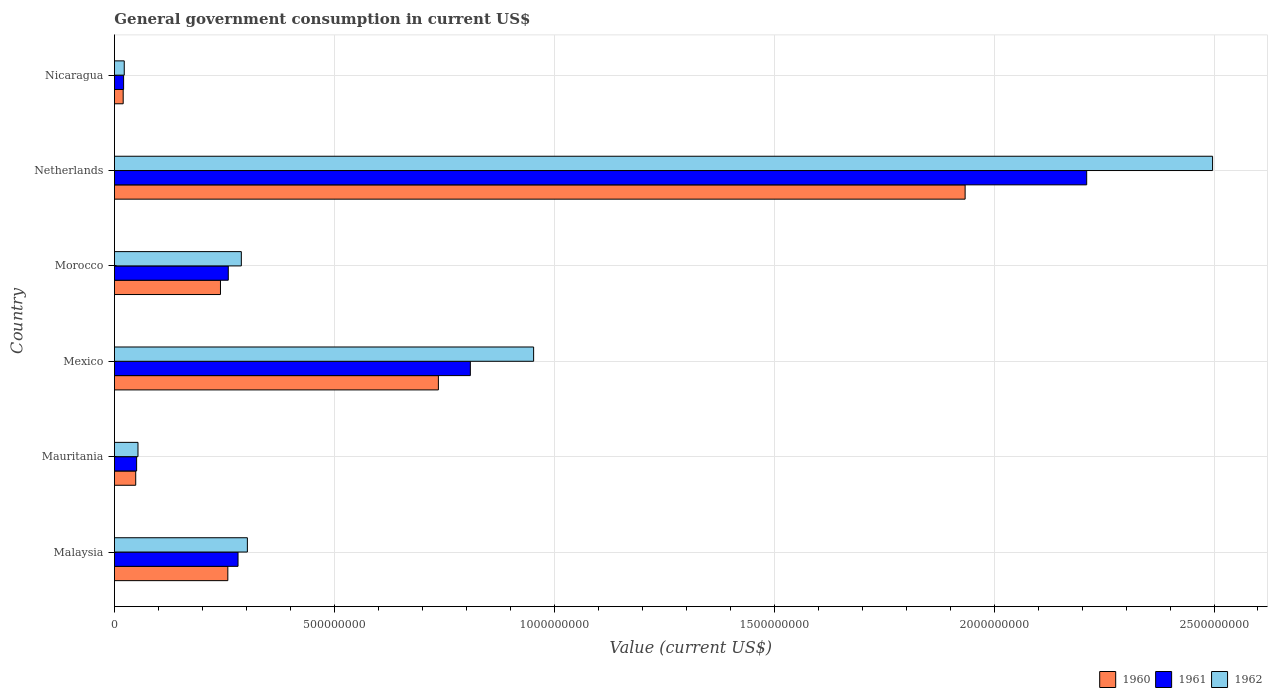How many bars are there on the 3rd tick from the top?
Your answer should be very brief. 3. What is the label of the 2nd group of bars from the top?
Provide a short and direct response. Netherlands. In how many cases, is the number of bars for a given country not equal to the number of legend labels?
Provide a short and direct response. 0. What is the government conusmption in 1962 in Netherlands?
Offer a very short reply. 2.50e+09. Across all countries, what is the maximum government conusmption in 1960?
Provide a short and direct response. 1.93e+09. Across all countries, what is the minimum government conusmption in 1962?
Offer a very short reply. 2.23e+07. In which country was the government conusmption in 1961 maximum?
Provide a succinct answer. Netherlands. In which country was the government conusmption in 1960 minimum?
Your response must be concise. Nicaragua. What is the total government conusmption in 1962 in the graph?
Ensure brevity in your answer.  4.12e+09. What is the difference between the government conusmption in 1961 in Mauritania and that in Netherlands?
Ensure brevity in your answer.  -2.16e+09. What is the difference between the government conusmption in 1961 in Netherlands and the government conusmption in 1960 in Mauritania?
Your response must be concise. 2.16e+09. What is the average government conusmption in 1961 per country?
Ensure brevity in your answer.  6.05e+08. What is the difference between the government conusmption in 1962 and government conusmption in 1961 in Morocco?
Keep it short and to the point. 2.96e+07. What is the ratio of the government conusmption in 1961 in Malaysia to that in Morocco?
Provide a succinct answer. 1.09. What is the difference between the highest and the second highest government conusmption in 1960?
Offer a very short reply. 1.20e+09. What is the difference between the highest and the lowest government conusmption in 1962?
Provide a succinct answer. 2.47e+09. In how many countries, is the government conusmption in 1960 greater than the average government conusmption in 1960 taken over all countries?
Your response must be concise. 2. Is the sum of the government conusmption in 1962 in Mauritania and Mexico greater than the maximum government conusmption in 1960 across all countries?
Give a very brief answer. No. Are all the bars in the graph horizontal?
Provide a short and direct response. Yes. What is the difference between two consecutive major ticks on the X-axis?
Make the answer very short. 5.00e+08. Are the values on the major ticks of X-axis written in scientific E-notation?
Your answer should be compact. No. Does the graph contain any zero values?
Provide a succinct answer. No. Does the graph contain grids?
Give a very brief answer. Yes. Where does the legend appear in the graph?
Keep it short and to the point. Bottom right. What is the title of the graph?
Provide a short and direct response. General government consumption in current US$. Does "1994" appear as one of the legend labels in the graph?
Ensure brevity in your answer.  No. What is the label or title of the X-axis?
Offer a very short reply. Value (current US$). What is the label or title of the Y-axis?
Give a very brief answer. Country. What is the Value (current US$) of 1960 in Malaysia?
Your answer should be compact. 2.58e+08. What is the Value (current US$) in 1961 in Malaysia?
Provide a short and direct response. 2.81e+08. What is the Value (current US$) in 1962 in Malaysia?
Give a very brief answer. 3.02e+08. What is the Value (current US$) of 1960 in Mauritania?
Provide a succinct answer. 4.84e+07. What is the Value (current US$) of 1961 in Mauritania?
Offer a very short reply. 5.05e+07. What is the Value (current US$) in 1962 in Mauritania?
Keep it short and to the point. 5.36e+07. What is the Value (current US$) in 1960 in Mexico?
Make the answer very short. 7.37e+08. What is the Value (current US$) in 1961 in Mexico?
Offer a terse response. 8.09e+08. What is the Value (current US$) in 1962 in Mexico?
Keep it short and to the point. 9.53e+08. What is the Value (current US$) of 1960 in Morocco?
Offer a very short reply. 2.41e+08. What is the Value (current US$) of 1961 in Morocco?
Offer a very short reply. 2.59e+08. What is the Value (current US$) in 1962 in Morocco?
Ensure brevity in your answer.  2.89e+08. What is the Value (current US$) in 1960 in Netherlands?
Provide a short and direct response. 1.93e+09. What is the Value (current US$) in 1961 in Netherlands?
Keep it short and to the point. 2.21e+09. What is the Value (current US$) in 1962 in Netherlands?
Ensure brevity in your answer.  2.50e+09. What is the Value (current US$) in 1960 in Nicaragua?
Ensure brevity in your answer.  1.99e+07. What is the Value (current US$) in 1961 in Nicaragua?
Your answer should be compact. 2.09e+07. What is the Value (current US$) of 1962 in Nicaragua?
Your answer should be compact. 2.23e+07. Across all countries, what is the maximum Value (current US$) of 1960?
Provide a short and direct response. 1.93e+09. Across all countries, what is the maximum Value (current US$) of 1961?
Offer a terse response. 2.21e+09. Across all countries, what is the maximum Value (current US$) of 1962?
Your response must be concise. 2.50e+09. Across all countries, what is the minimum Value (current US$) in 1960?
Ensure brevity in your answer.  1.99e+07. Across all countries, what is the minimum Value (current US$) of 1961?
Make the answer very short. 2.09e+07. Across all countries, what is the minimum Value (current US$) of 1962?
Provide a short and direct response. 2.23e+07. What is the total Value (current US$) of 1960 in the graph?
Make the answer very short. 3.24e+09. What is the total Value (current US$) of 1961 in the graph?
Your response must be concise. 3.63e+09. What is the total Value (current US$) in 1962 in the graph?
Make the answer very short. 4.12e+09. What is the difference between the Value (current US$) of 1960 in Malaysia and that in Mauritania?
Offer a terse response. 2.09e+08. What is the difference between the Value (current US$) of 1961 in Malaysia and that in Mauritania?
Your answer should be very brief. 2.31e+08. What is the difference between the Value (current US$) in 1962 in Malaysia and that in Mauritania?
Ensure brevity in your answer.  2.49e+08. What is the difference between the Value (current US$) of 1960 in Malaysia and that in Mexico?
Give a very brief answer. -4.79e+08. What is the difference between the Value (current US$) of 1961 in Malaysia and that in Mexico?
Your response must be concise. -5.28e+08. What is the difference between the Value (current US$) in 1962 in Malaysia and that in Mexico?
Your answer should be compact. -6.51e+08. What is the difference between the Value (current US$) in 1960 in Malaysia and that in Morocco?
Give a very brief answer. 1.67e+07. What is the difference between the Value (current US$) of 1961 in Malaysia and that in Morocco?
Offer a terse response. 2.21e+07. What is the difference between the Value (current US$) in 1962 in Malaysia and that in Morocco?
Keep it short and to the point. 1.37e+07. What is the difference between the Value (current US$) of 1960 in Malaysia and that in Netherlands?
Offer a very short reply. -1.68e+09. What is the difference between the Value (current US$) in 1961 in Malaysia and that in Netherlands?
Provide a short and direct response. -1.93e+09. What is the difference between the Value (current US$) of 1962 in Malaysia and that in Netherlands?
Your answer should be very brief. -2.19e+09. What is the difference between the Value (current US$) of 1960 in Malaysia and that in Nicaragua?
Make the answer very short. 2.38e+08. What is the difference between the Value (current US$) in 1961 in Malaysia and that in Nicaragua?
Keep it short and to the point. 2.60e+08. What is the difference between the Value (current US$) in 1962 in Malaysia and that in Nicaragua?
Your response must be concise. 2.80e+08. What is the difference between the Value (current US$) in 1960 in Mauritania and that in Mexico?
Ensure brevity in your answer.  -6.88e+08. What is the difference between the Value (current US$) of 1961 in Mauritania and that in Mexico?
Offer a terse response. -7.59e+08. What is the difference between the Value (current US$) of 1962 in Mauritania and that in Mexico?
Make the answer very short. -9.00e+08. What is the difference between the Value (current US$) of 1960 in Mauritania and that in Morocco?
Provide a succinct answer. -1.93e+08. What is the difference between the Value (current US$) in 1961 in Mauritania and that in Morocco?
Provide a succinct answer. -2.08e+08. What is the difference between the Value (current US$) in 1962 in Mauritania and that in Morocco?
Your answer should be very brief. -2.35e+08. What is the difference between the Value (current US$) in 1960 in Mauritania and that in Netherlands?
Give a very brief answer. -1.89e+09. What is the difference between the Value (current US$) of 1961 in Mauritania and that in Netherlands?
Keep it short and to the point. -2.16e+09. What is the difference between the Value (current US$) of 1962 in Mauritania and that in Netherlands?
Your answer should be compact. -2.44e+09. What is the difference between the Value (current US$) in 1960 in Mauritania and that in Nicaragua?
Provide a short and direct response. 2.85e+07. What is the difference between the Value (current US$) of 1961 in Mauritania and that in Nicaragua?
Offer a very short reply. 2.96e+07. What is the difference between the Value (current US$) in 1962 in Mauritania and that in Nicaragua?
Keep it short and to the point. 3.12e+07. What is the difference between the Value (current US$) of 1960 in Mexico and that in Morocco?
Your answer should be compact. 4.95e+08. What is the difference between the Value (current US$) of 1961 in Mexico and that in Morocco?
Give a very brief answer. 5.50e+08. What is the difference between the Value (current US$) of 1962 in Mexico and that in Morocco?
Offer a very short reply. 6.65e+08. What is the difference between the Value (current US$) in 1960 in Mexico and that in Netherlands?
Make the answer very short. -1.20e+09. What is the difference between the Value (current US$) in 1961 in Mexico and that in Netherlands?
Your response must be concise. -1.40e+09. What is the difference between the Value (current US$) of 1962 in Mexico and that in Netherlands?
Offer a terse response. -1.54e+09. What is the difference between the Value (current US$) of 1960 in Mexico and that in Nicaragua?
Give a very brief answer. 7.17e+08. What is the difference between the Value (current US$) of 1961 in Mexico and that in Nicaragua?
Keep it short and to the point. 7.88e+08. What is the difference between the Value (current US$) in 1962 in Mexico and that in Nicaragua?
Offer a very short reply. 9.31e+08. What is the difference between the Value (current US$) of 1960 in Morocco and that in Netherlands?
Provide a succinct answer. -1.69e+09. What is the difference between the Value (current US$) of 1961 in Morocco and that in Netherlands?
Offer a very short reply. -1.95e+09. What is the difference between the Value (current US$) of 1962 in Morocco and that in Netherlands?
Your answer should be compact. -2.21e+09. What is the difference between the Value (current US$) in 1960 in Morocco and that in Nicaragua?
Your answer should be compact. 2.21e+08. What is the difference between the Value (current US$) of 1961 in Morocco and that in Nicaragua?
Ensure brevity in your answer.  2.38e+08. What is the difference between the Value (current US$) in 1962 in Morocco and that in Nicaragua?
Provide a short and direct response. 2.66e+08. What is the difference between the Value (current US$) in 1960 in Netherlands and that in Nicaragua?
Give a very brief answer. 1.91e+09. What is the difference between the Value (current US$) of 1961 in Netherlands and that in Nicaragua?
Your response must be concise. 2.19e+09. What is the difference between the Value (current US$) in 1962 in Netherlands and that in Nicaragua?
Offer a terse response. 2.47e+09. What is the difference between the Value (current US$) of 1960 in Malaysia and the Value (current US$) of 1961 in Mauritania?
Offer a very short reply. 2.07e+08. What is the difference between the Value (current US$) of 1960 in Malaysia and the Value (current US$) of 1962 in Mauritania?
Provide a short and direct response. 2.04e+08. What is the difference between the Value (current US$) in 1961 in Malaysia and the Value (current US$) in 1962 in Mauritania?
Ensure brevity in your answer.  2.27e+08. What is the difference between the Value (current US$) of 1960 in Malaysia and the Value (current US$) of 1961 in Mexico?
Your response must be concise. -5.51e+08. What is the difference between the Value (current US$) of 1960 in Malaysia and the Value (current US$) of 1962 in Mexico?
Keep it short and to the point. -6.95e+08. What is the difference between the Value (current US$) of 1961 in Malaysia and the Value (current US$) of 1962 in Mexico?
Offer a very short reply. -6.72e+08. What is the difference between the Value (current US$) of 1960 in Malaysia and the Value (current US$) of 1961 in Morocco?
Give a very brief answer. -1.04e+06. What is the difference between the Value (current US$) of 1960 in Malaysia and the Value (current US$) of 1962 in Morocco?
Keep it short and to the point. -3.07e+07. What is the difference between the Value (current US$) of 1961 in Malaysia and the Value (current US$) of 1962 in Morocco?
Keep it short and to the point. -7.50e+06. What is the difference between the Value (current US$) of 1960 in Malaysia and the Value (current US$) of 1961 in Netherlands?
Provide a succinct answer. -1.95e+09. What is the difference between the Value (current US$) in 1960 in Malaysia and the Value (current US$) in 1962 in Netherlands?
Provide a succinct answer. -2.24e+09. What is the difference between the Value (current US$) of 1961 in Malaysia and the Value (current US$) of 1962 in Netherlands?
Provide a succinct answer. -2.22e+09. What is the difference between the Value (current US$) of 1960 in Malaysia and the Value (current US$) of 1961 in Nicaragua?
Ensure brevity in your answer.  2.37e+08. What is the difference between the Value (current US$) of 1960 in Malaysia and the Value (current US$) of 1962 in Nicaragua?
Provide a succinct answer. 2.35e+08. What is the difference between the Value (current US$) of 1961 in Malaysia and the Value (current US$) of 1962 in Nicaragua?
Ensure brevity in your answer.  2.59e+08. What is the difference between the Value (current US$) in 1960 in Mauritania and the Value (current US$) in 1961 in Mexico?
Give a very brief answer. -7.61e+08. What is the difference between the Value (current US$) in 1960 in Mauritania and the Value (current US$) in 1962 in Mexico?
Give a very brief answer. -9.05e+08. What is the difference between the Value (current US$) in 1961 in Mauritania and the Value (current US$) in 1962 in Mexico?
Provide a short and direct response. -9.03e+08. What is the difference between the Value (current US$) of 1960 in Mauritania and the Value (current US$) of 1961 in Morocco?
Offer a terse response. -2.10e+08. What is the difference between the Value (current US$) in 1960 in Mauritania and the Value (current US$) in 1962 in Morocco?
Your answer should be very brief. -2.40e+08. What is the difference between the Value (current US$) in 1961 in Mauritania and the Value (current US$) in 1962 in Morocco?
Ensure brevity in your answer.  -2.38e+08. What is the difference between the Value (current US$) in 1960 in Mauritania and the Value (current US$) in 1961 in Netherlands?
Your answer should be very brief. -2.16e+09. What is the difference between the Value (current US$) in 1960 in Mauritania and the Value (current US$) in 1962 in Netherlands?
Offer a terse response. -2.45e+09. What is the difference between the Value (current US$) of 1961 in Mauritania and the Value (current US$) of 1962 in Netherlands?
Give a very brief answer. -2.45e+09. What is the difference between the Value (current US$) in 1960 in Mauritania and the Value (current US$) in 1961 in Nicaragua?
Ensure brevity in your answer.  2.75e+07. What is the difference between the Value (current US$) in 1960 in Mauritania and the Value (current US$) in 1962 in Nicaragua?
Provide a succinct answer. 2.61e+07. What is the difference between the Value (current US$) of 1961 in Mauritania and the Value (current US$) of 1962 in Nicaragua?
Offer a very short reply. 2.81e+07. What is the difference between the Value (current US$) of 1960 in Mexico and the Value (current US$) of 1961 in Morocco?
Offer a terse response. 4.78e+08. What is the difference between the Value (current US$) in 1960 in Mexico and the Value (current US$) in 1962 in Morocco?
Give a very brief answer. 4.48e+08. What is the difference between the Value (current US$) of 1961 in Mexico and the Value (current US$) of 1962 in Morocco?
Your answer should be compact. 5.21e+08. What is the difference between the Value (current US$) in 1960 in Mexico and the Value (current US$) in 1961 in Netherlands?
Make the answer very short. -1.47e+09. What is the difference between the Value (current US$) in 1960 in Mexico and the Value (current US$) in 1962 in Netherlands?
Offer a very short reply. -1.76e+09. What is the difference between the Value (current US$) of 1961 in Mexico and the Value (current US$) of 1962 in Netherlands?
Offer a very short reply. -1.69e+09. What is the difference between the Value (current US$) in 1960 in Mexico and the Value (current US$) in 1961 in Nicaragua?
Ensure brevity in your answer.  7.16e+08. What is the difference between the Value (current US$) in 1960 in Mexico and the Value (current US$) in 1962 in Nicaragua?
Provide a succinct answer. 7.14e+08. What is the difference between the Value (current US$) of 1961 in Mexico and the Value (current US$) of 1962 in Nicaragua?
Offer a terse response. 7.87e+08. What is the difference between the Value (current US$) of 1960 in Morocco and the Value (current US$) of 1961 in Netherlands?
Offer a terse response. -1.97e+09. What is the difference between the Value (current US$) in 1960 in Morocco and the Value (current US$) in 1962 in Netherlands?
Provide a short and direct response. -2.26e+09. What is the difference between the Value (current US$) in 1961 in Morocco and the Value (current US$) in 1962 in Netherlands?
Keep it short and to the point. -2.24e+09. What is the difference between the Value (current US$) of 1960 in Morocco and the Value (current US$) of 1961 in Nicaragua?
Ensure brevity in your answer.  2.20e+08. What is the difference between the Value (current US$) of 1960 in Morocco and the Value (current US$) of 1962 in Nicaragua?
Offer a very short reply. 2.19e+08. What is the difference between the Value (current US$) of 1961 in Morocco and the Value (current US$) of 1962 in Nicaragua?
Provide a short and direct response. 2.37e+08. What is the difference between the Value (current US$) of 1960 in Netherlands and the Value (current US$) of 1961 in Nicaragua?
Offer a terse response. 1.91e+09. What is the difference between the Value (current US$) of 1960 in Netherlands and the Value (current US$) of 1962 in Nicaragua?
Give a very brief answer. 1.91e+09. What is the difference between the Value (current US$) in 1961 in Netherlands and the Value (current US$) in 1962 in Nicaragua?
Your response must be concise. 2.19e+09. What is the average Value (current US$) of 1960 per country?
Offer a very short reply. 5.40e+08. What is the average Value (current US$) in 1961 per country?
Your answer should be very brief. 6.05e+08. What is the average Value (current US$) in 1962 per country?
Your response must be concise. 6.86e+08. What is the difference between the Value (current US$) of 1960 and Value (current US$) of 1961 in Malaysia?
Provide a short and direct response. -2.32e+07. What is the difference between the Value (current US$) of 1960 and Value (current US$) of 1962 in Malaysia?
Offer a terse response. -4.44e+07. What is the difference between the Value (current US$) in 1961 and Value (current US$) in 1962 in Malaysia?
Your answer should be very brief. -2.12e+07. What is the difference between the Value (current US$) in 1960 and Value (current US$) in 1961 in Mauritania?
Your answer should be compact. -2.06e+06. What is the difference between the Value (current US$) of 1960 and Value (current US$) of 1962 in Mauritania?
Provide a succinct answer. -5.15e+06. What is the difference between the Value (current US$) of 1961 and Value (current US$) of 1962 in Mauritania?
Provide a succinct answer. -3.09e+06. What is the difference between the Value (current US$) in 1960 and Value (current US$) in 1961 in Mexico?
Ensure brevity in your answer.  -7.27e+07. What is the difference between the Value (current US$) in 1960 and Value (current US$) in 1962 in Mexico?
Your response must be concise. -2.17e+08. What is the difference between the Value (current US$) in 1961 and Value (current US$) in 1962 in Mexico?
Your answer should be compact. -1.44e+08. What is the difference between the Value (current US$) of 1960 and Value (current US$) of 1961 in Morocco?
Offer a terse response. -1.78e+07. What is the difference between the Value (current US$) in 1960 and Value (current US$) in 1962 in Morocco?
Ensure brevity in your answer.  -4.74e+07. What is the difference between the Value (current US$) in 1961 and Value (current US$) in 1962 in Morocco?
Your answer should be very brief. -2.96e+07. What is the difference between the Value (current US$) in 1960 and Value (current US$) in 1961 in Netherlands?
Keep it short and to the point. -2.76e+08. What is the difference between the Value (current US$) of 1960 and Value (current US$) of 1962 in Netherlands?
Make the answer very short. -5.63e+08. What is the difference between the Value (current US$) in 1961 and Value (current US$) in 1962 in Netherlands?
Make the answer very short. -2.86e+08. What is the difference between the Value (current US$) of 1960 and Value (current US$) of 1961 in Nicaragua?
Make the answer very short. -9.72e+05. What is the difference between the Value (current US$) in 1960 and Value (current US$) in 1962 in Nicaragua?
Give a very brief answer. -2.43e+06. What is the difference between the Value (current US$) of 1961 and Value (current US$) of 1962 in Nicaragua?
Give a very brief answer. -1.46e+06. What is the ratio of the Value (current US$) in 1960 in Malaysia to that in Mauritania?
Make the answer very short. 5.33. What is the ratio of the Value (current US$) of 1961 in Malaysia to that in Mauritania?
Your answer should be compact. 5.57. What is the ratio of the Value (current US$) in 1962 in Malaysia to that in Mauritania?
Ensure brevity in your answer.  5.64. What is the ratio of the Value (current US$) of 1960 in Malaysia to that in Mexico?
Provide a short and direct response. 0.35. What is the ratio of the Value (current US$) of 1961 in Malaysia to that in Mexico?
Your answer should be very brief. 0.35. What is the ratio of the Value (current US$) in 1962 in Malaysia to that in Mexico?
Make the answer very short. 0.32. What is the ratio of the Value (current US$) of 1960 in Malaysia to that in Morocco?
Offer a terse response. 1.07. What is the ratio of the Value (current US$) in 1961 in Malaysia to that in Morocco?
Ensure brevity in your answer.  1.09. What is the ratio of the Value (current US$) in 1962 in Malaysia to that in Morocco?
Provide a short and direct response. 1.05. What is the ratio of the Value (current US$) in 1960 in Malaysia to that in Netherlands?
Provide a succinct answer. 0.13. What is the ratio of the Value (current US$) in 1961 in Malaysia to that in Netherlands?
Provide a short and direct response. 0.13. What is the ratio of the Value (current US$) in 1962 in Malaysia to that in Netherlands?
Your response must be concise. 0.12. What is the ratio of the Value (current US$) of 1960 in Malaysia to that in Nicaragua?
Your answer should be compact. 12.94. What is the ratio of the Value (current US$) of 1961 in Malaysia to that in Nicaragua?
Keep it short and to the point. 13.45. What is the ratio of the Value (current US$) in 1962 in Malaysia to that in Nicaragua?
Ensure brevity in your answer.  13.53. What is the ratio of the Value (current US$) in 1960 in Mauritania to that in Mexico?
Keep it short and to the point. 0.07. What is the ratio of the Value (current US$) of 1961 in Mauritania to that in Mexico?
Provide a short and direct response. 0.06. What is the ratio of the Value (current US$) of 1962 in Mauritania to that in Mexico?
Your answer should be very brief. 0.06. What is the ratio of the Value (current US$) in 1960 in Mauritania to that in Morocco?
Give a very brief answer. 0.2. What is the ratio of the Value (current US$) in 1961 in Mauritania to that in Morocco?
Your answer should be very brief. 0.2. What is the ratio of the Value (current US$) of 1962 in Mauritania to that in Morocco?
Provide a short and direct response. 0.19. What is the ratio of the Value (current US$) in 1960 in Mauritania to that in Netherlands?
Provide a short and direct response. 0.03. What is the ratio of the Value (current US$) of 1961 in Mauritania to that in Netherlands?
Your answer should be very brief. 0.02. What is the ratio of the Value (current US$) in 1962 in Mauritania to that in Netherlands?
Provide a short and direct response. 0.02. What is the ratio of the Value (current US$) in 1960 in Mauritania to that in Nicaragua?
Make the answer very short. 2.43. What is the ratio of the Value (current US$) in 1961 in Mauritania to that in Nicaragua?
Offer a terse response. 2.42. What is the ratio of the Value (current US$) in 1962 in Mauritania to that in Nicaragua?
Keep it short and to the point. 2.4. What is the ratio of the Value (current US$) in 1960 in Mexico to that in Morocco?
Offer a terse response. 3.06. What is the ratio of the Value (current US$) of 1961 in Mexico to that in Morocco?
Offer a terse response. 3.13. What is the ratio of the Value (current US$) of 1962 in Mexico to that in Morocco?
Ensure brevity in your answer.  3.3. What is the ratio of the Value (current US$) of 1960 in Mexico to that in Netherlands?
Provide a succinct answer. 0.38. What is the ratio of the Value (current US$) in 1961 in Mexico to that in Netherlands?
Your answer should be very brief. 0.37. What is the ratio of the Value (current US$) in 1962 in Mexico to that in Netherlands?
Offer a very short reply. 0.38. What is the ratio of the Value (current US$) of 1960 in Mexico to that in Nicaragua?
Provide a short and direct response. 36.98. What is the ratio of the Value (current US$) of 1961 in Mexico to that in Nicaragua?
Make the answer very short. 38.74. What is the ratio of the Value (current US$) in 1962 in Mexico to that in Nicaragua?
Offer a terse response. 42.65. What is the ratio of the Value (current US$) of 1960 in Morocco to that in Netherlands?
Offer a very short reply. 0.12. What is the ratio of the Value (current US$) in 1961 in Morocco to that in Netherlands?
Offer a terse response. 0.12. What is the ratio of the Value (current US$) in 1962 in Morocco to that in Netherlands?
Offer a very short reply. 0.12. What is the ratio of the Value (current US$) of 1960 in Morocco to that in Nicaragua?
Offer a terse response. 12.1. What is the ratio of the Value (current US$) of 1961 in Morocco to that in Nicaragua?
Give a very brief answer. 12.39. What is the ratio of the Value (current US$) in 1962 in Morocco to that in Nicaragua?
Offer a very short reply. 12.91. What is the ratio of the Value (current US$) of 1960 in Netherlands to that in Nicaragua?
Your response must be concise. 97.11. What is the ratio of the Value (current US$) of 1961 in Netherlands to that in Nicaragua?
Your response must be concise. 105.82. What is the ratio of the Value (current US$) of 1962 in Netherlands to that in Nicaragua?
Keep it short and to the point. 111.73. What is the difference between the highest and the second highest Value (current US$) in 1960?
Provide a succinct answer. 1.20e+09. What is the difference between the highest and the second highest Value (current US$) of 1961?
Your answer should be compact. 1.40e+09. What is the difference between the highest and the second highest Value (current US$) of 1962?
Provide a succinct answer. 1.54e+09. What is the difference between the highest and the lowest Value (current US$) of 1960?
Offer a terse response. 1.91e+09. What is the difference between the highest and the lowest Value (current US$) of 1961?
Make the answer very short. 2.19e+09. What is the difference between the highest and the lowest Value (current US$) of 1962?
Ensure brevity in your answer.  2.47e+09. 